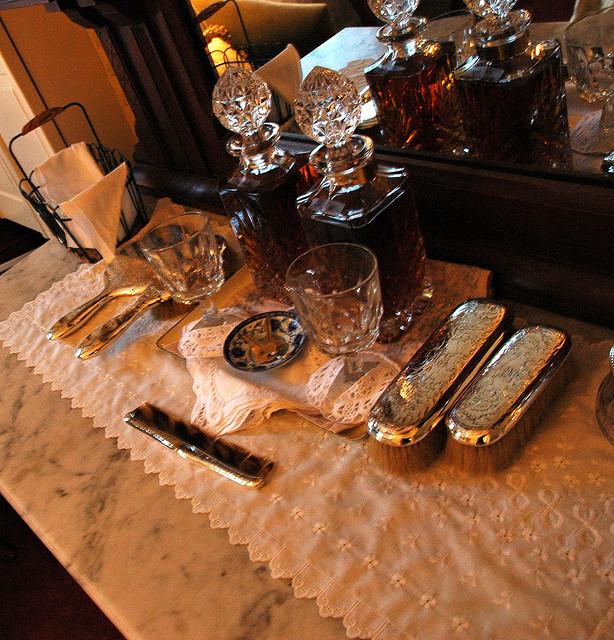What is the table made out of?
Concise answer only. Marble. Is there a mirror in this photo?
Answer briefly. Yes. How many people in the photo?
Short answer required. 0. 